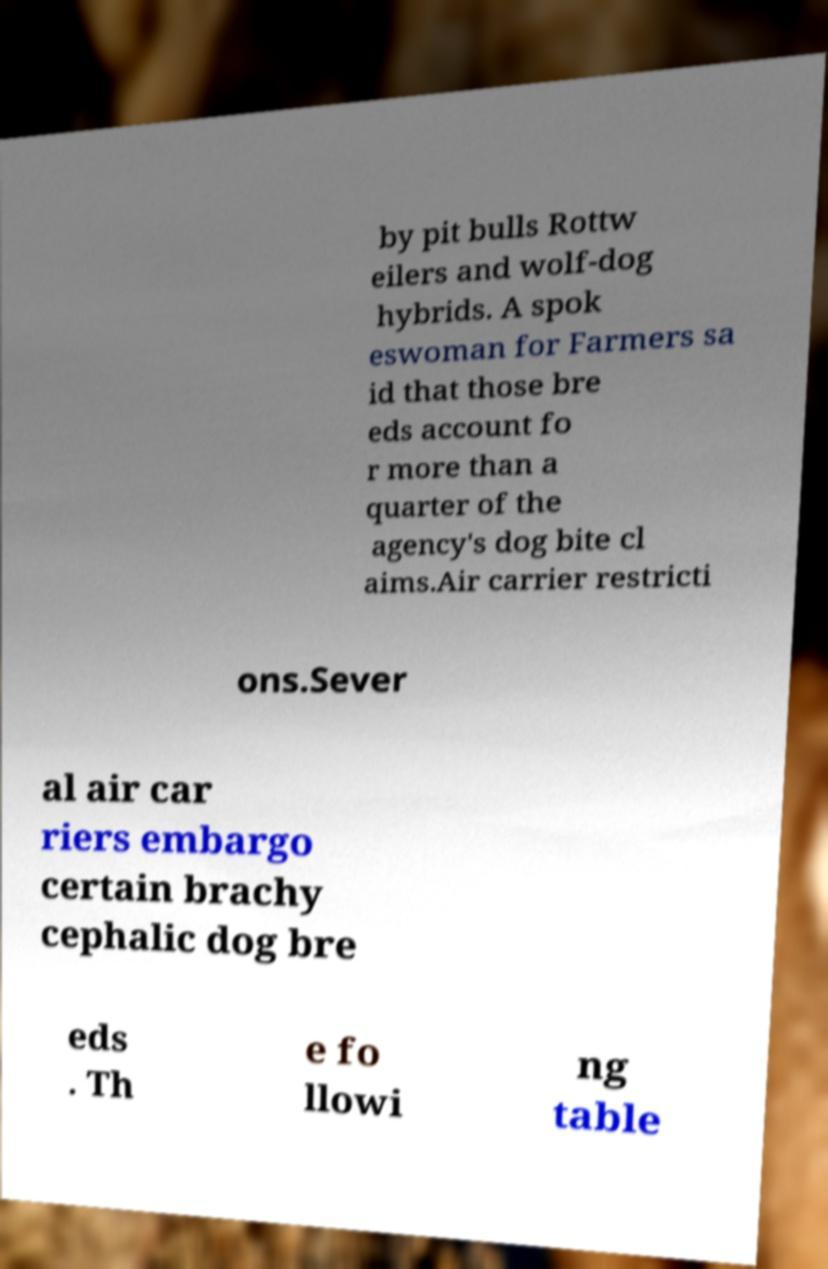What messages or text are displayed in this image? I need them in a readable, typed format. by pit bulls Rottw eilers and wolf-dog hybrids. A spok eswoman for Farmers sa id that those bre eds account fo r more than a quarter of the agency's dog bite cl aims.Air carrier restricti ons.Sever al air car riers embargo certain brachy cephalic dog bre eds . Th e fo llowi ng table 